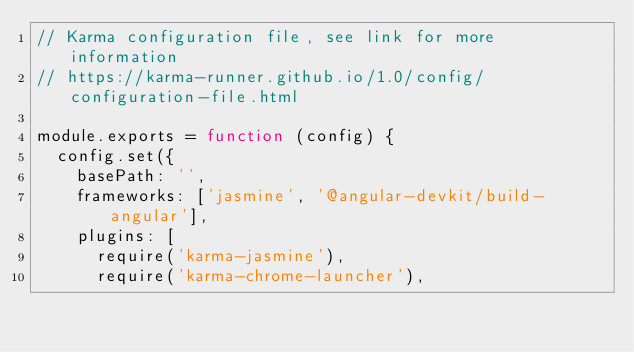<code> <loc_0><loc_0><loc_500><loc_500><_JavaScript_>// Karma configuration file, see link for more information
// https://karma-runner.github.io/1.0/config/configuration-file.html

module.exports = function (config) {
  config.set({
    basePath: '',
    frameworks: ['jasmine', '@angular-devkit/build-angular'],
    plugins: [
      require('karma-jasmine'),
      require('karma-chrome-launcher'),</code> 